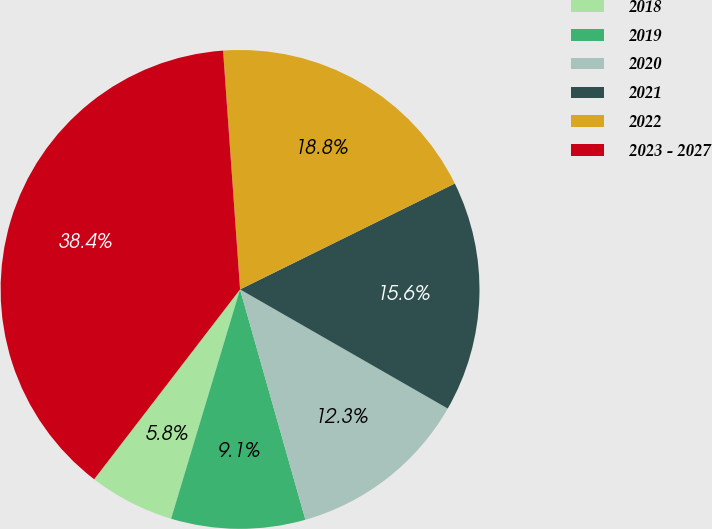<chart> <loc_0><loc_0><loc_500><loc_500><pie_chart><fcel>2018<fcel>2019<fcel>2020<fcel>2021<fcel>2022<fcel>2023 - 2027<nl><fcel>5.78%<fcel>9.05%<fcel>12.31%<fcel>15.58%<fcel>18.84%<fcel>38.44%<nl></chart> 